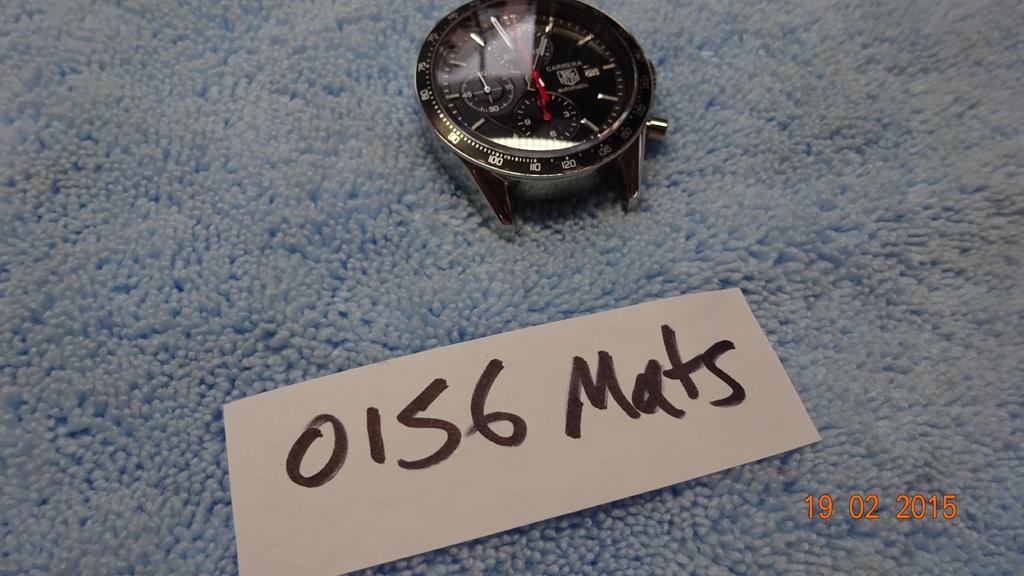What brand of watch is this?
Offer a very short reply. Carrera. What date is on the image?
Offer a terse response. 19 02 2015. 